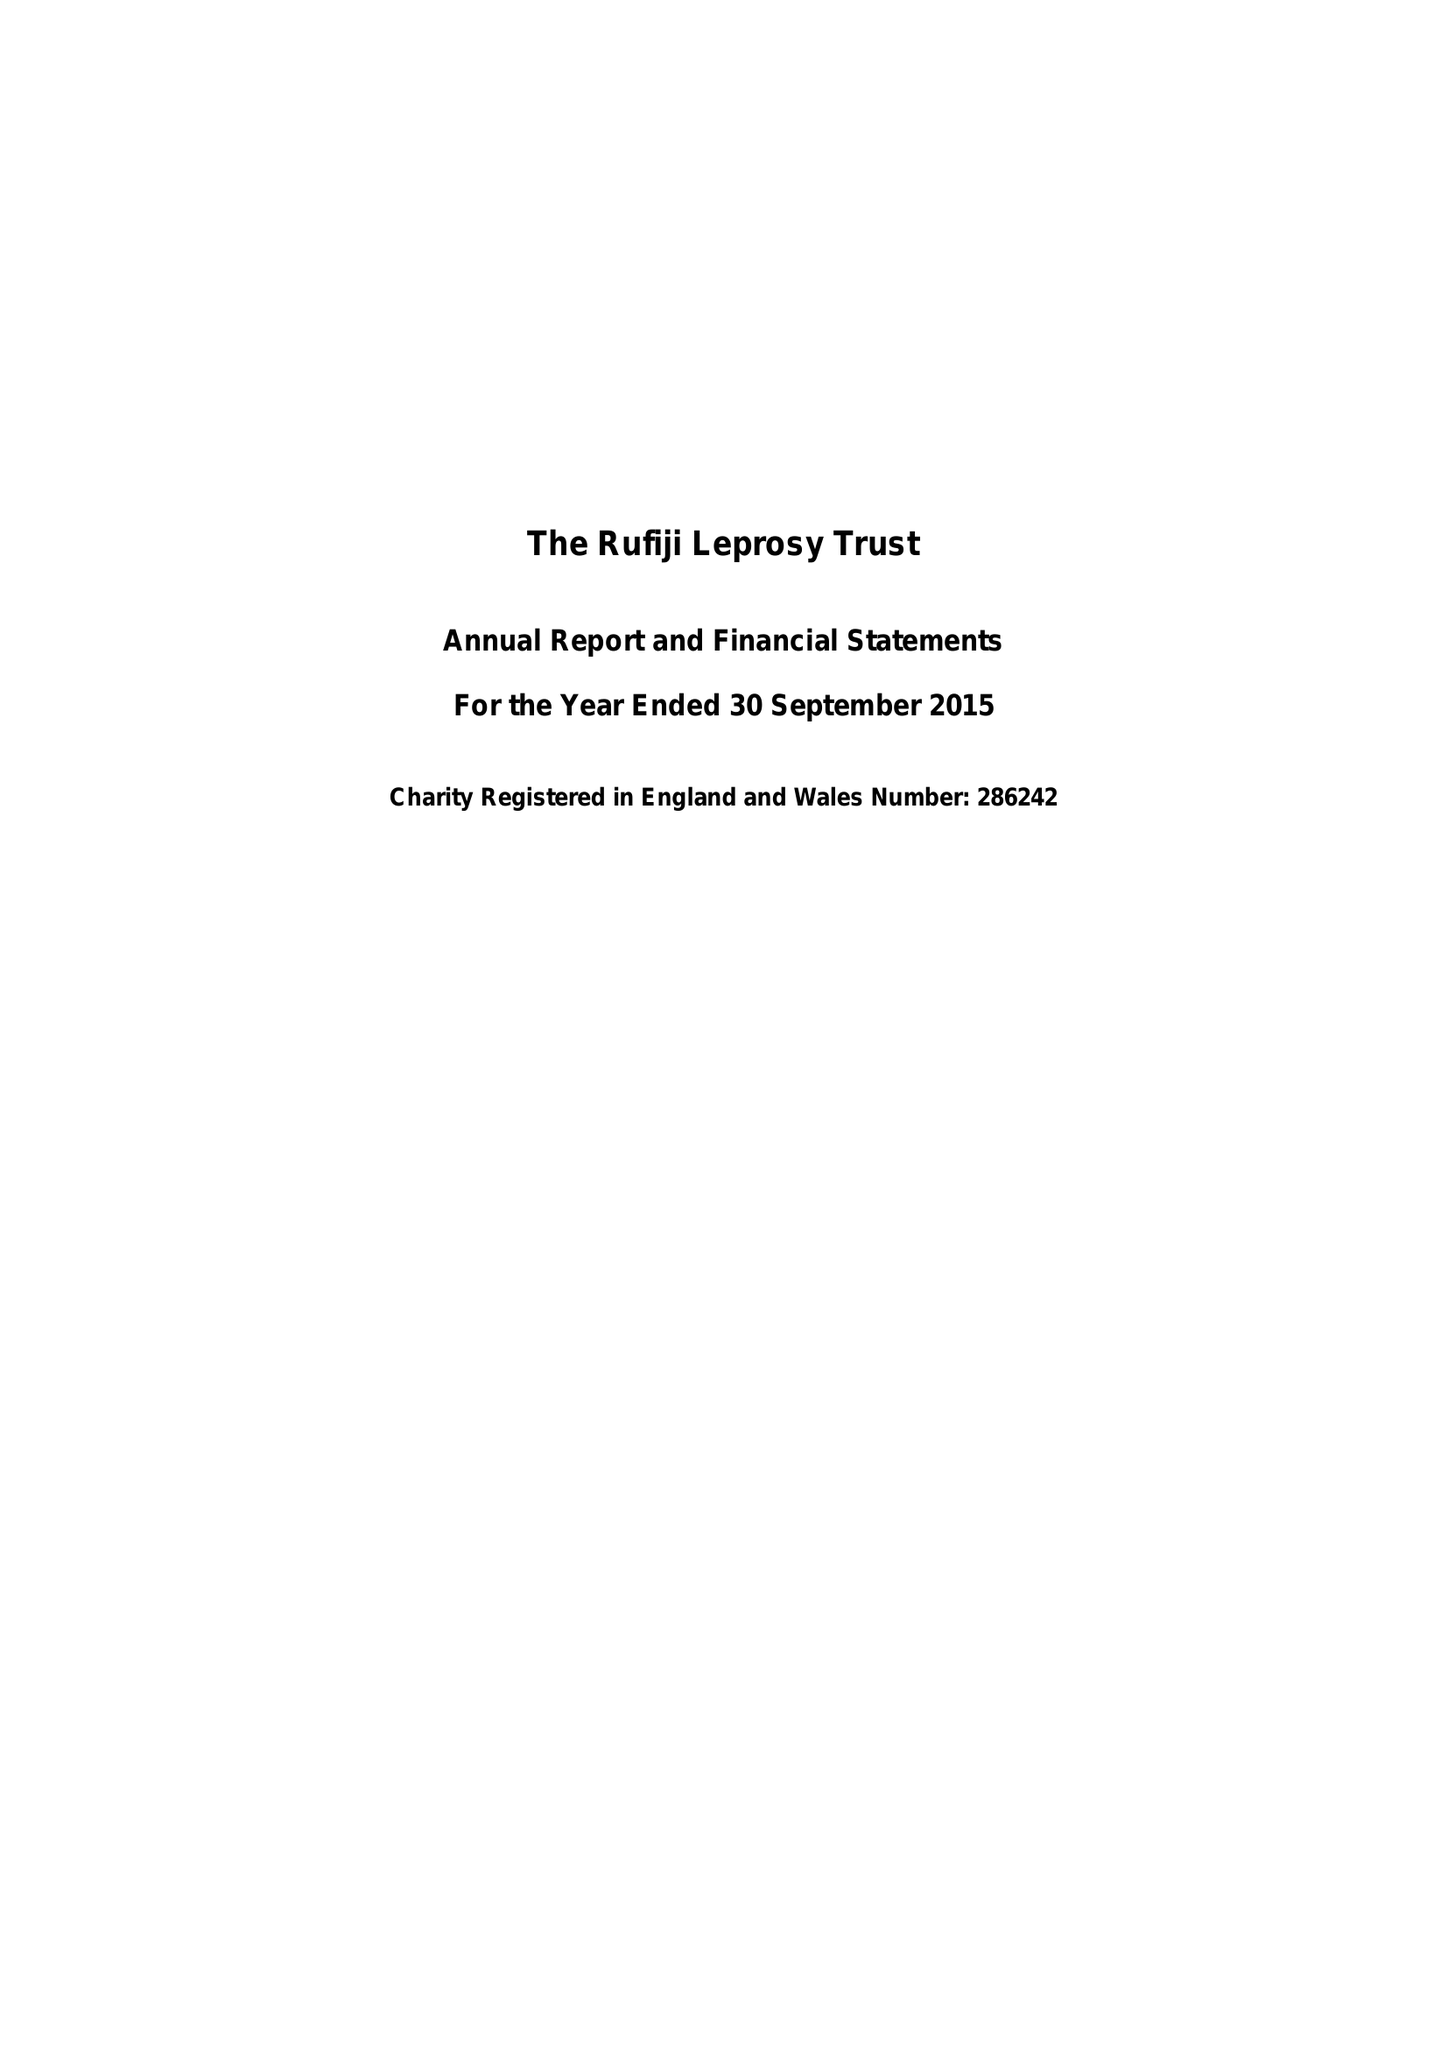What is the value for the spending_annually_in_british_pounds?
Answer the question using a single word or phrase. 52176.00 